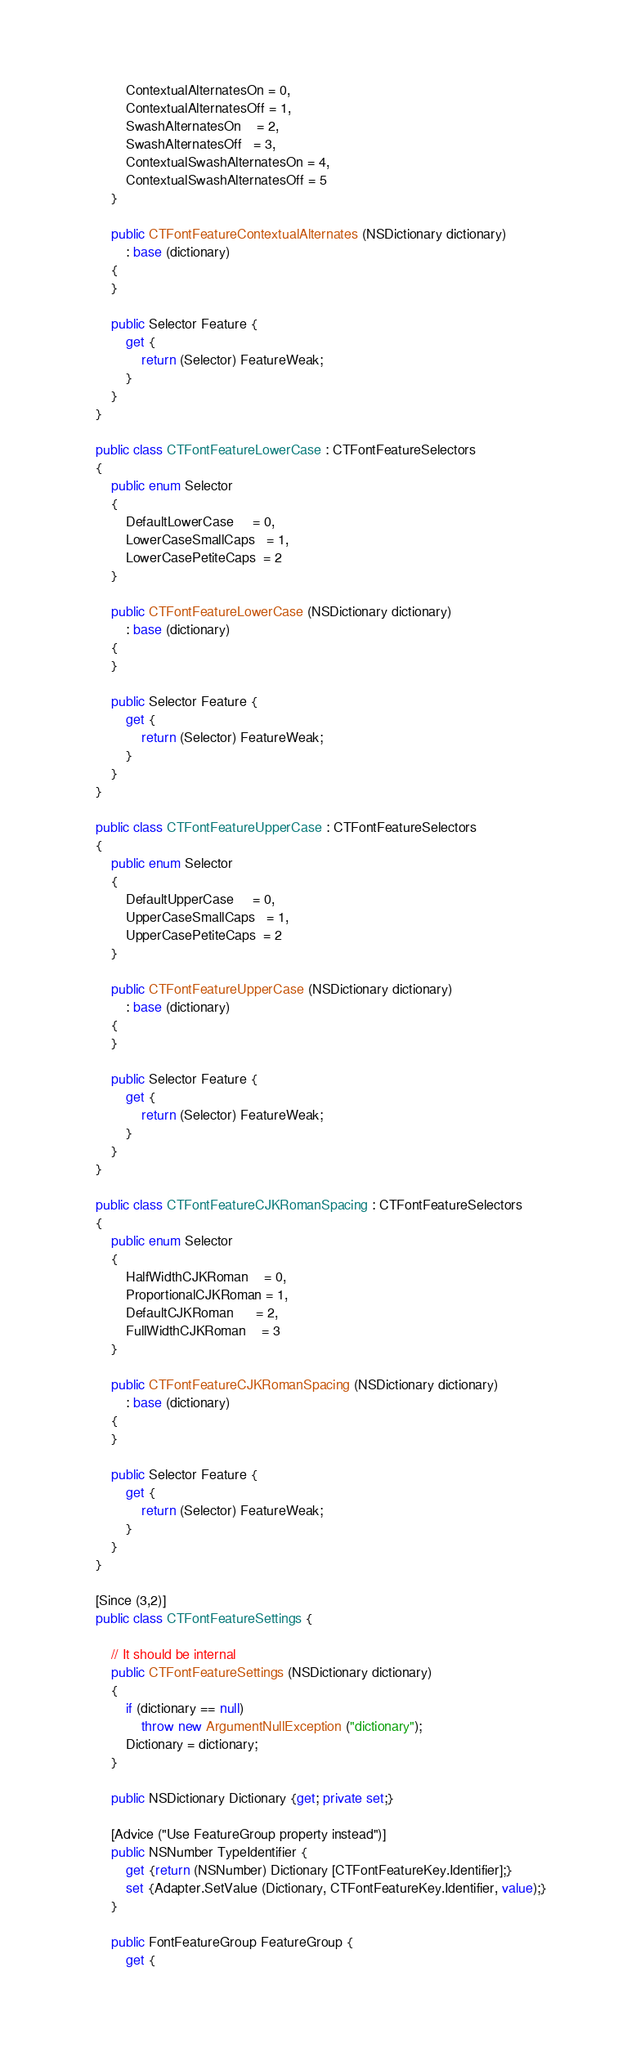Convert code to text. <code><loc_0><loc_0><loc_500><loc_500><_C#_>			ContextualAlternatesOn = 0,
			ContextualAlternatesOff = 1,
			SwashAlternatesOn    = 2,
			SwashAlternatesOff   = 3,
			ContextualSwashAlternatesOn = 4,
			ContextualSwashAlternatesOff = 5
		}

		public CTFontFeatureContextualAlternates (NSDictionary dictionary)
			: base (dictionary)
		{
		}

		public Selector Feature {
			get {
				return (Selector) FeatureWeak;
			}
		}
	}

	public class CTFontFeatureLowerCase : CTFontFeatureSelectors
	{
		public enum Selector
		{
			DefaultLowerCase     = 0,
			LowerCaseSmallCaps   = 1,
			LowerCasePetiteCaps  = 2
		}

		public CTFontFeatureLowerCase (NSDictionary dictionary)
			: base (dictionary)
		{
		}

		public Selector Feature {
			get {
				return (Selector) FeatureWeak;
			}
		}
	}

	public class CTFontFeatureUpperCase : CTFontFeatureSelectors
	{
		public enum Selector
		{
			DefaultUpperCase     = 0,
			UpperCaseSmallCaps   = 1,
			UpperCasePetiteCaps  = 2
		}

		public CTFontFeatureUpperCase (NSDictionary dictionary)
			: base (dictionary)
		{
		}

		public Selector Feature {
			get {
				return (Selector) FeatureWeak;
			}
		}
	}

	public class CTFontFeatureCJKRomanSpacing : CTFontFeatureSelectors
	{
		public enum Selector
		{
			HalfWidthCJKRoman    = 0,
			ProportionalCJKRoman = 1,
			DefaultCJKRoman      = 2,
			FullWidthCJKRoman    = 3
		}

		public CTFontFeatureCJKRomanSpacing (NSDictionary dictionary)
			: base (dictionary)
		{
		}

		public Selector Feature {
			get {
				return (Selector) FeatureWeak;
			}
		}
	}

	[Since (3,2)]
	public class CTFontFeatureSettings {

		// It should be internal
		public CTFontFeatureSettings (NSDictionary dictionary)
		{
			if (dictionary == null)
				throw new ArgumentNullException ("dictionary");
			Dictionary = dictionary;
		}

		public NSDictionary Dictionary {get; private set;}

		[Advice ("Use FeatureGroup property instead")]
		public NSNumber TypeIdentifier {
			get {return (NSNumber) Dictionary [CTFontFeatureKey.Identifier];}
			set {Adapter.SetValue (Dictionary, CTFontFeatureKey.Identifier, value);}
		}

		public FontFeatureGroup FeatureGroup {
			get {</code> 